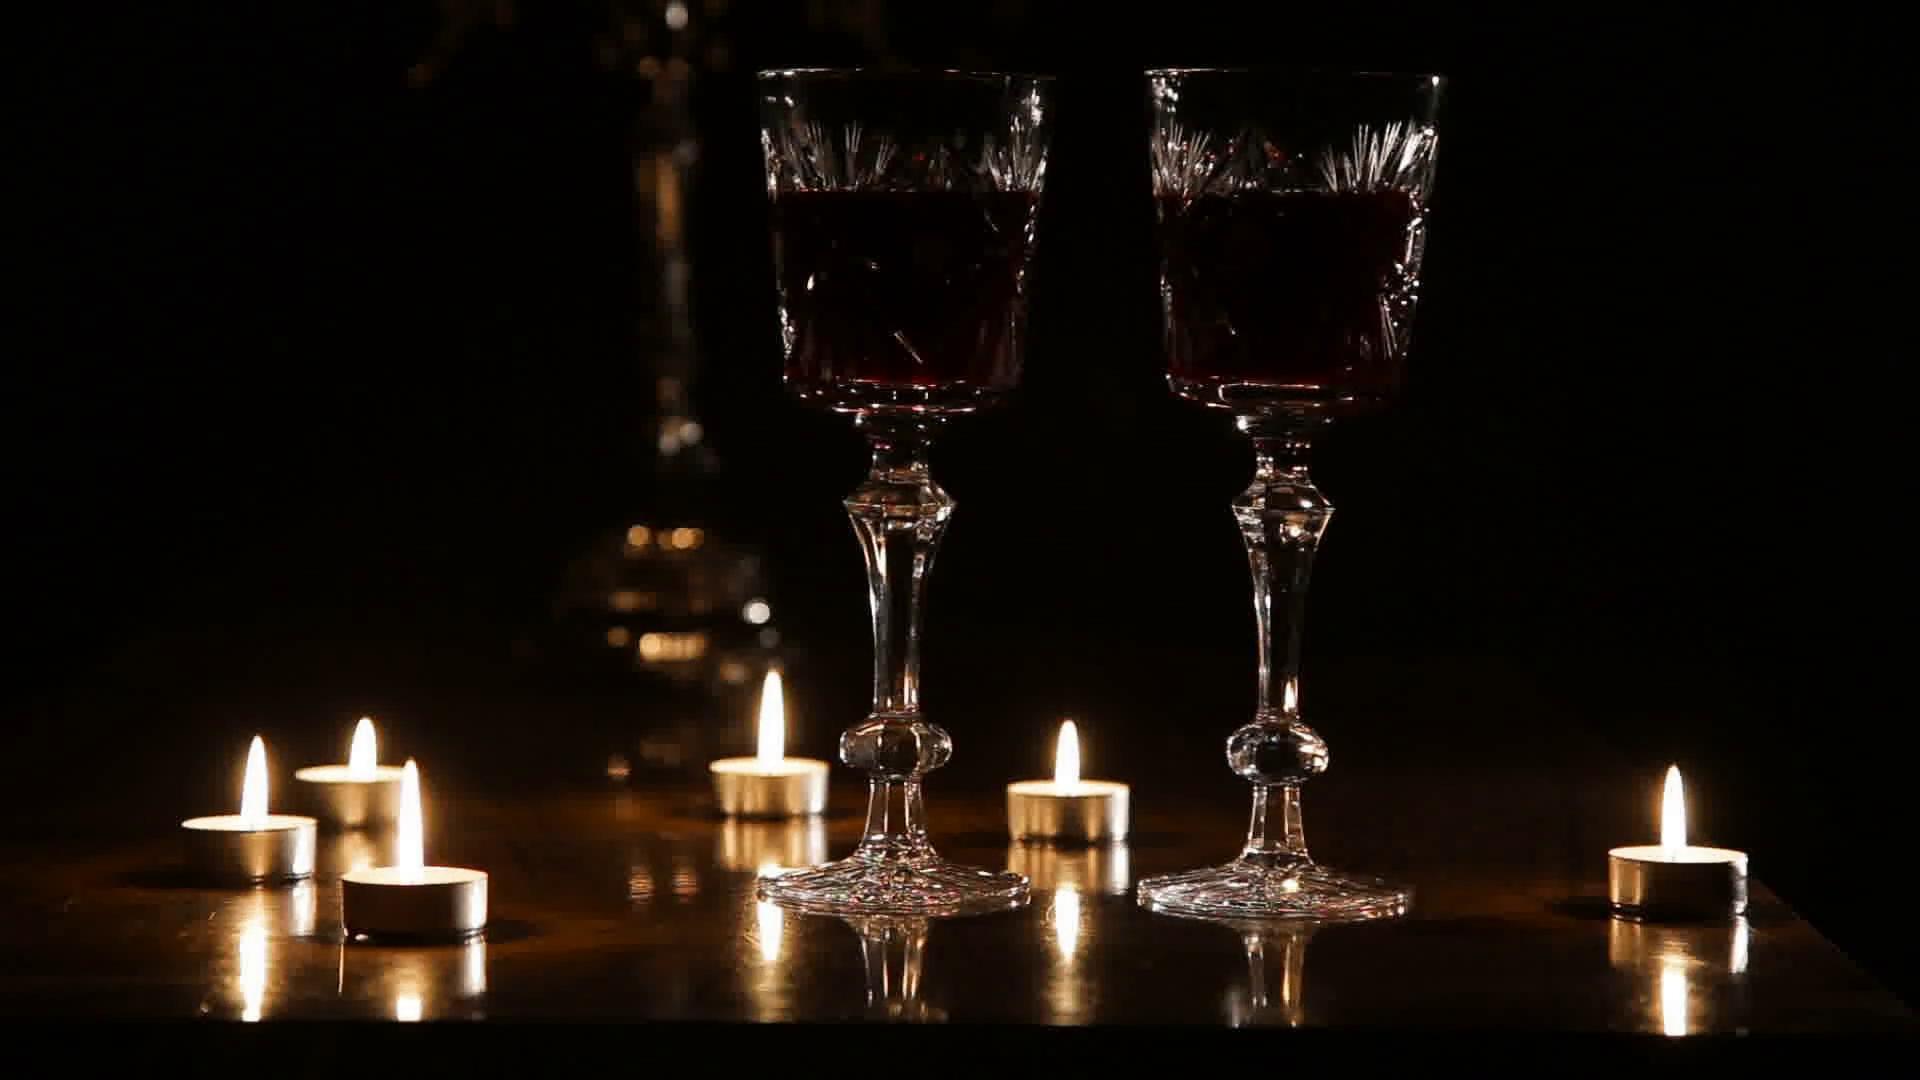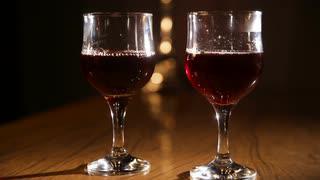The first image is the image on the left, the second image is the image on the right. Examine the images to the left and right. Is the description "An image shows wisps of white smoke around two glasses of dark red wine, standing near candles." accurate? Answer yes or no. No. 